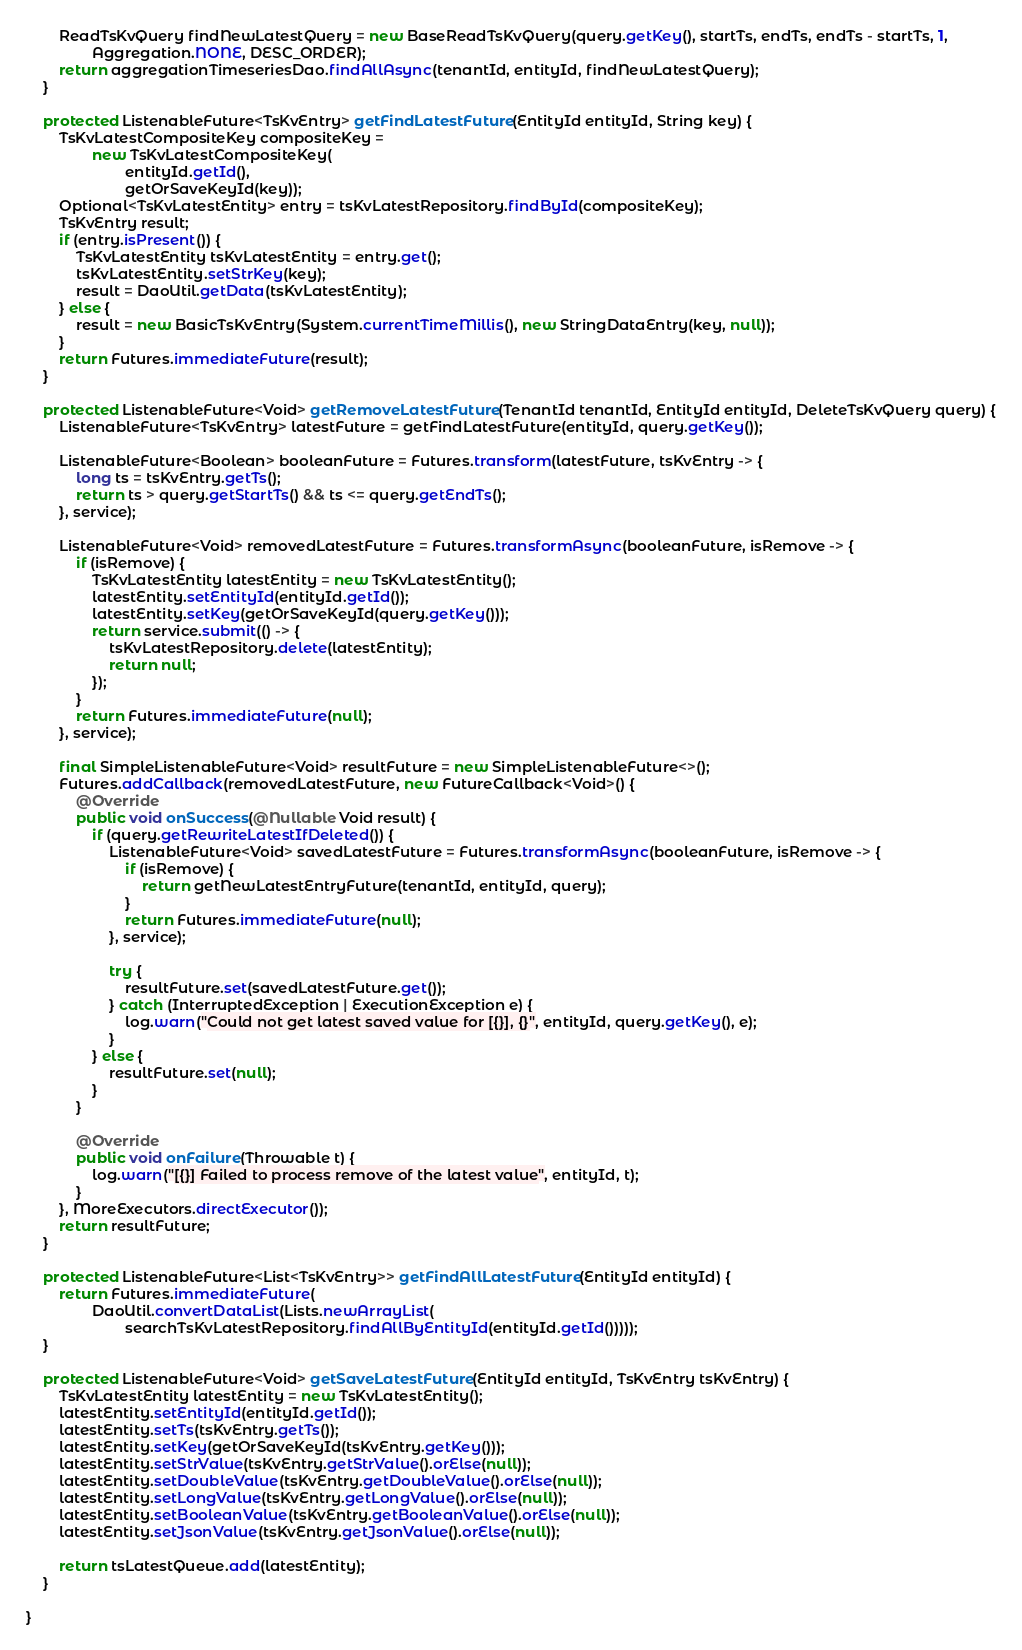<code> <loc_0><loc_0><loc_500><loc_500><_Java_>        ReadTsKvQuery findNewLatestQuery = new BaseReadTsKvQuery(query.getKey(), startTs, endTs, endTs - startTs, 1,
                Aggregation.NONE, DESC_ORDER);
        return aggregationTimeseriesDao.findAllAsync(tenantId, entityId, findNewLatestQuery);
    }

    protected ListenableFuture<TsKvEntry> getFindLatestFuture(EntityId entityId, String key) {
        TsKvLatestCompositeKey compositeKey =
                new TsKvLatestCompositeKey(
                        entityId.getId(),
                        getOrSaveKeyId(key));
        Optional<TsKvLatestEntity> entry = tsKvLatestRepository.findById(compositeKey);
        TsKvEntry result;
        if (entry.isPresent()) {
            TsKvLatestEntity tsKvLatestEntity = entry.get();
            tsKvLatestEntity.setStrKey(key);
            result = DaoUtil.getData(tsKvLatestEntity);
        } else {
            result = new BasicTsKvEntry(System.currentTimeMillis(), new StringDataEntry(key, null));
        }
        return Futures.immediateFuture(result);
    }

    protected ListenableFuture<Void> getRemoveLatestFuture(TenantId tenantId, EntityId entityId, DeleteTsKvQuery query) {
        ListenableFuture<TsKvEntry> latestFuture = getFindLatestFuture(entityId, query.getKey());

        ListenableFuture<Boolean> booleanFuture = Futures.transform(latestFuture, tsKvEntry -> {
            long ts = tsKvEntry.getTs();
            return ts > query.getStartTs() && ts <= query.getEndTs();
        }, service);

        ListenableFuture<Void> removedLatestFuture = Futures.transformAsync(booleanFuture, isRemove -> {
            if (isRemove) {
                TsKvLatestEntity latestEntity = new TsKvLatestEntity();
                latestEntity.setEntityId(entityId.getId());
                latestEntity.setKey(getOrSaveKeyId(query.getKey()));
                return service.submit(() -> {
                    tsKvLatestRepository.delete(latestEntity);
                    return null;
                });
            }
            return Futures.immediateFuture(null);
        }, service);

        final SimpleListenableFuture<Void> resultFuture = new SimpleListenableFuture<>();
        Futures.addCallback(removedLatestFuture, new FutureCallback<Void>() {
            @Override
            public void onSuccess(@Nullable Void result) {
                if (query.getRewriteLatestIfDeleted()) {
                    ListenableFuture<Void> savedLatestFuture = Futures.transformAsync(booleanFuture, isRemove -> {
                        if (isRemove) {
                            return getNewLatestEntryFuture(tenantId, entityId, query);
                        }
                        return Futures.immediateFuture(null);
                    }, service);

                    try {
                        resultFuture.set(savedLatestFuture.get());
                    } catch (InterruptedException | ExecutionException e) {
                        log.warn("Could not get latest saved value for [{}], {}", entityId, query.getKey(), e);
                    }
                } else {
                    resultFuture.set(null);
                }
            }

            @Override
            public void onFailure(Throwable t) {
                log.warn("[{}] Failed to process remove of the latest value", entityId, t);
            }
        }, MoreExecutors.directExecutor());
        return resultFuture;
    }

    protected ListenableFuture<List<TsKvEntry>> getFindAllLatestFuture(EntityId entityId) {
        return Futures.immediateFuture(
                DaoUtil.convertDataList(Lists.newArrayList(
                        searchTsKvLatestRepository.findAllByEntityId(entityId.getId()))));
    }

    protected ListenableFuture<Void> getSaveLatestFuture(EntityId entityId, TsKvEntry tsKvEntry) {
        TsKvLatestEntity latestEntity = new TsKvLatestEntity();
        latestEntity.setEntityId(entityId.getId());
        latestEntity.setTs(tsKvEntry.getTs());
        latestEntity.setKey(getOrSaveKeyId(tsKvEntry.getKey()));
        latestEntity.setStrValue(tsKvEntry.getStrValue().orElse(null));
        latestEntity.setDoubleValue(tsKvEntry.getDoubleValue().orElse(null));
        latestEntity.setLongValue(tsKvEntry.getLongValue().orElse(null));
        latestEntity.setBooleanValue(tsKvEntry.getBooleanValue().orElse(null));
        latestEntity.setJsonValue(tsKvEntry.getJsonValue().orElse(null));

        return tsLatestQueue.add(latestEntity);
    }

}
</code> 